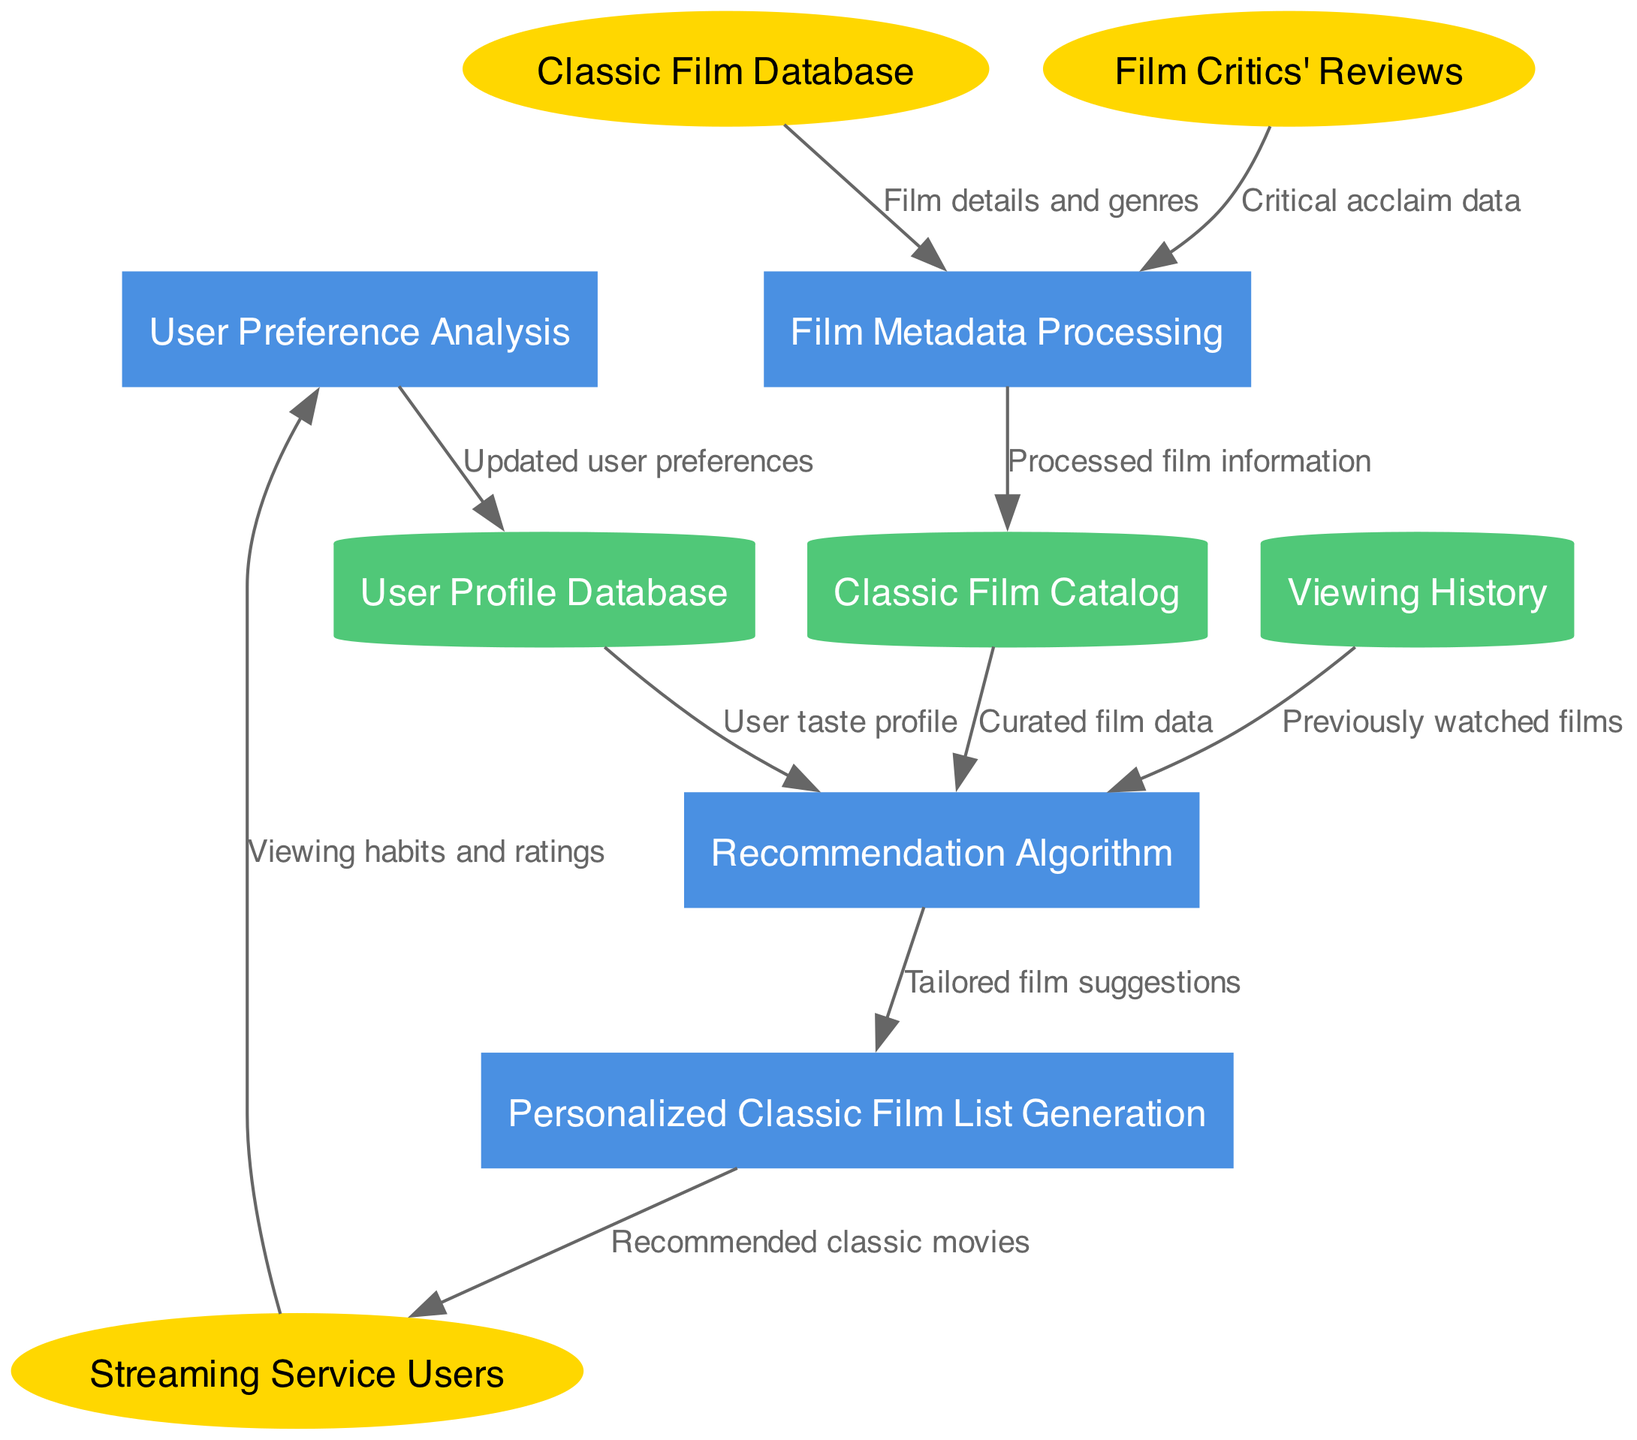What are the external entities in this diagram? The diagram includes three external entities which are represented as ellipses. By reviewing the external entity nodes, I identify "Streaming Service Users," "Classic Film Database," and "Film Critics' Reviews."
Answer: Streaming Service Users, Classic Film Database, Film Critics' Reviews How many processes are depicted in the diagram? The diagram contains four processes which are rectangular shapes. By counting the number of process nodes, I identify "User Preference Analysis," "Film Metadata Processing," "Recommendation Algorithm," and "Personalized Classic Film List Generation."
Answer: 4 What flows from Streaming Service Users to User Preference Analysis? The edge between the "Streaming Service Users" and "User Preference Analysis" is labeled "Viewing habits and ratings." This label states the type of data being sent from one node to the other.
Answer: Viewing habits and ratings Which data store receives processed film information? From the edge labeled "Processed film information," I trace the flow from "Film Metadata Processing" to the "Classic Film Catalog." Therefore, the "Classic Film Catalog" is the data store that receives this information.
Answer: Classic Film Catalog What two inputs does the Recommendation Algorithm use? To identify the inputs for the "Recommendation Algorithm," I examine the edges leading into it. They come from "User Profile Database" with a label "User taste profile," and from "Classic Film Catalog" with a label "Curated film data." Thus, the two inputs are "User taste profile" and "Curated film data."
Answer: User taste profile, Curated film data What is the final output generated in the data flow? The last process in the flow is "Personalized Classic Film List Generation," which outputs to "Streaming Service Users" the labeled edge "Recommended classic movies." Therefore, the final output is labeled as such.
Answer: Recommended classic movies Which process generates tailored film suggestions? The edge from "Recommendation Algorithm" to "Personalized Classic Film List Generation" is labeled "Tailored film suggestions." This indicates that the "Recommendation Algorithm" is responsible for creating these suggestions.
Answer: Recommendation Algorithm How many data stores are represented in the diagram? The diagram illustrates three data stores, which are depicted as cylinders. By counting the nodes labeled as data stores, I confirm these to be "User Profile Database," "Classic Film Catalog," and "Viewing History."
Answer: 3 What is the purpose of the Film Metadata Processing process? The "Film Metadata Processing" receives information from two external entities, namely "Classic Film Database" and "Film Critics' Reviews." It processes both "Film details and genres" and "Critical acclaim data," suggesting its role is to enrich film information prior to recommendations.
Answer: To enrich film information 